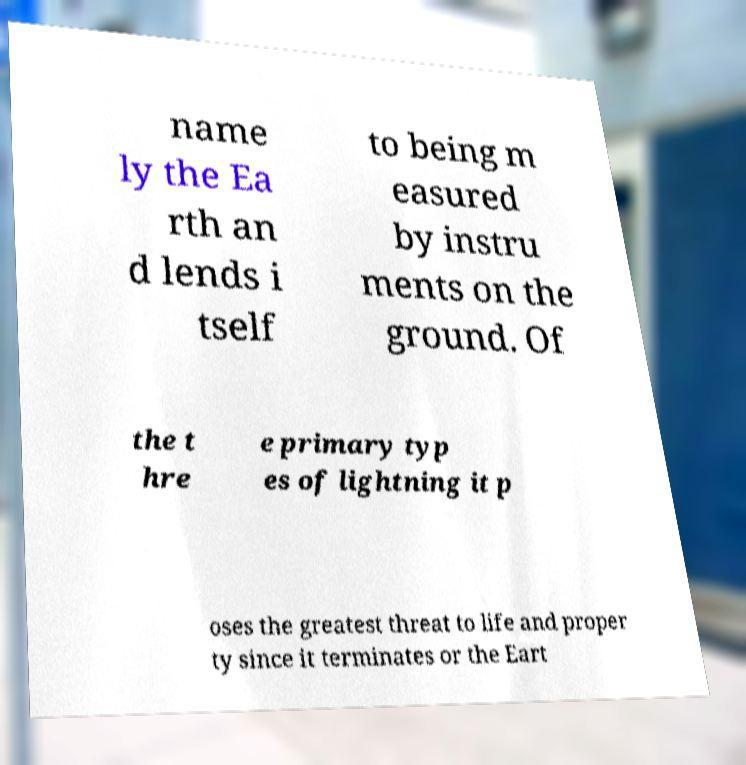There's text embedded in this image that I need extracted. Can you transcribe it verbatim? name ly the Ea rth an d lends i tself to being m easured by instru ments on the ground. Of the t hre e primary typ es of lightning it p oses the greatest threat to life and proper ty since it terminates or the Eart 